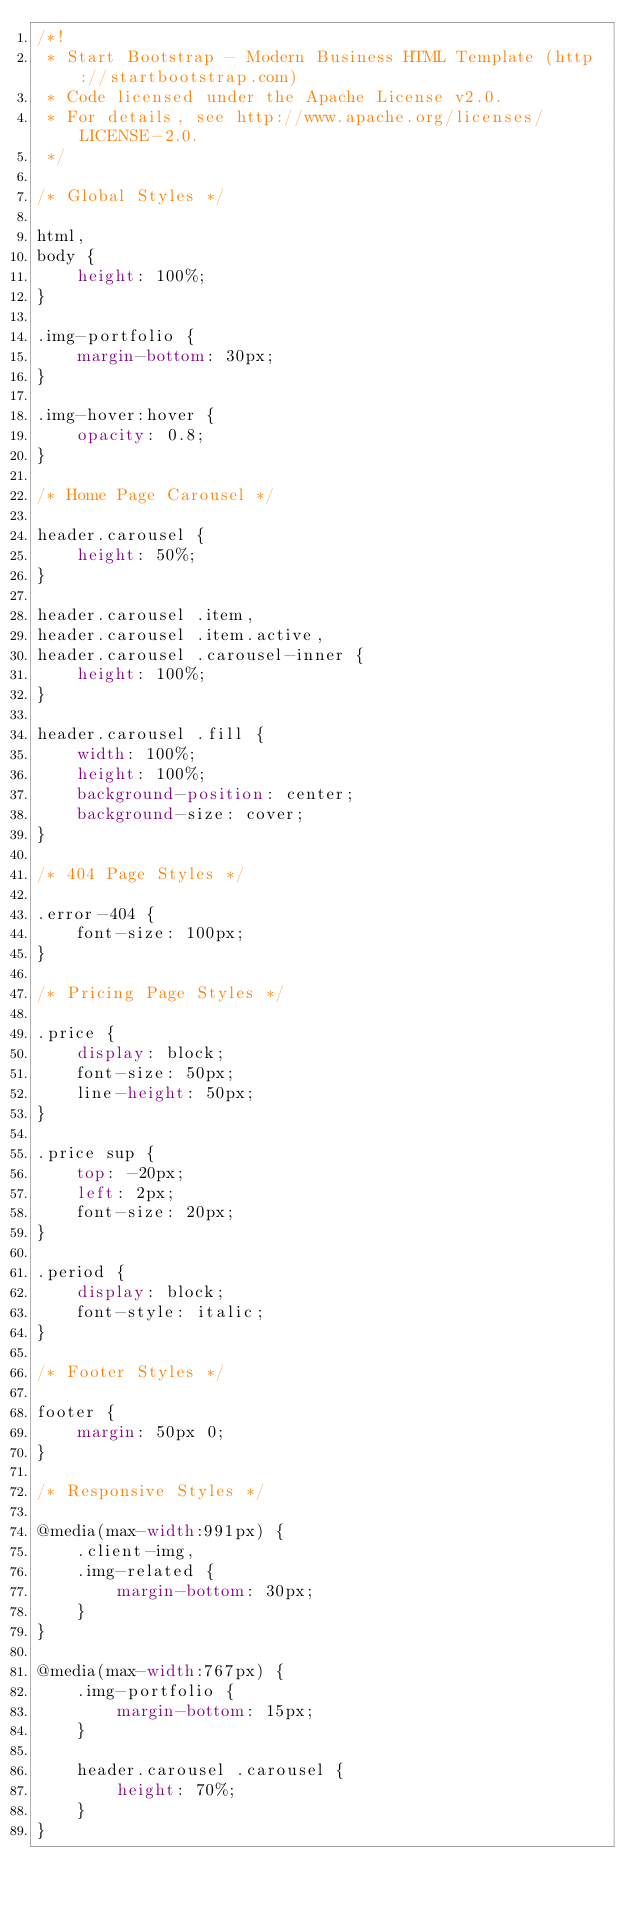<code> <loc_0><loc_0><loc_500><loc_500><_CSS_>/*!
 * Start Bootstrap - Modern Business HTML Template (http://startbootstrap.com)
 * Code licensed under the Apache License v2.0.
 * For details, see http://www.apache.org/licenses/LICENSE-2.0.
 */

/* Global Styles */

html,
body {
    height: 100%;
}

.img-portfolio {
    margin-bottom: 30px;
}

.img-hover:hover {
    opacity: 0.8;
}

/* Home Page Carousel */

header.carousel {
    height: 50%;
}

header.carousel .item,
header.carousel .item.active,
header.carousel .carousel-inner {
    height: 100%;
}

header.carousel .fill {
    width: 100%;
    height: 100%;
    background-position: center;
    background-size: cover;
}

/* 404 Page Styles */

.error-404 {
    font-size: 100px;
}

/* Pricing Page Styles */

.price {
    display: block;
    font-size: 50px;
    line-height: 50px;
}

.price sup {
    top: -20px;
    left: 2px;
    font-size: 20px;
}

.period {
    display: block;
    font-style: italic;
}

/* Footer Styles */

footer {
    margin: 50px 0;
}

/* Responsive Styles */

@media(max-width:991px) {
    .client-img,
    .img-related {
        margin-bottom: 30px;
    }
}

@media(max-width:767px) {
    .img-portfolio {
        margin-bottom: 15px;
    }

    header.carousel .carousel {
        height: 70%;
    }
}</code> 